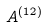Convert formula to latex. <formula><loc_0><loc_0><loc_500><loc_500>A ^ { ( 1 2 ) }</formula> 